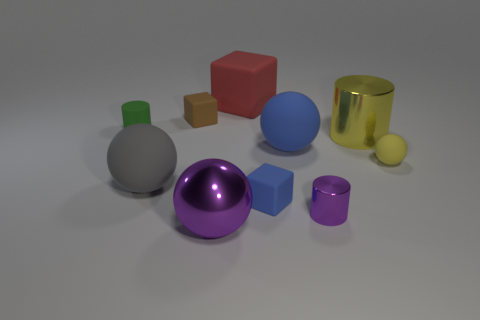Subtract all small blue matte cubes. How many cubes are left? 2 Subtract all gray spheres. How many spheres are left? 3 Subtract all green spheres. Subtract all gray cubes. How many spheres are left? 4 Subtract all cylinders. How many objects are left? 7 Subtract 0 cyan spheres. How many objects are left? 10 Subtract all small brown matte cylinders. Subtract all small balls. How many objects are left? 9 Add 8 big blue rubber things. How many big blue rubber things are left? 9 Add 9 brown metal things. How many brown metal things exist? 9 